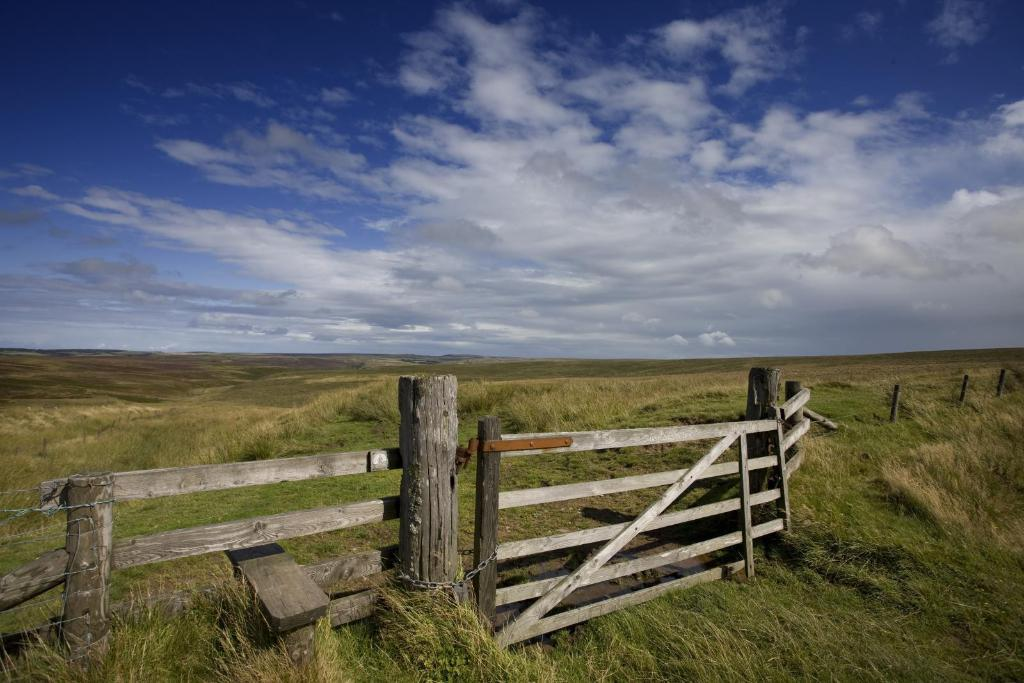What type of barrier can be seen in the image? There is a wooden fence and barrier poles present in the image. What material is the fence made of? The fence is made of wood. What can be found on the ground in the image? Lawn straw is visible in the image. What is visible in the background of the image? There are hills in the background of the image. What is visible in the sky in the image? The sky is visible in the image, and clouds are present. What is the weight of the truck in the image? There is no truck present in the image. How many crates are stacked on the wooden fence in the image? There are no crates present in the image. 